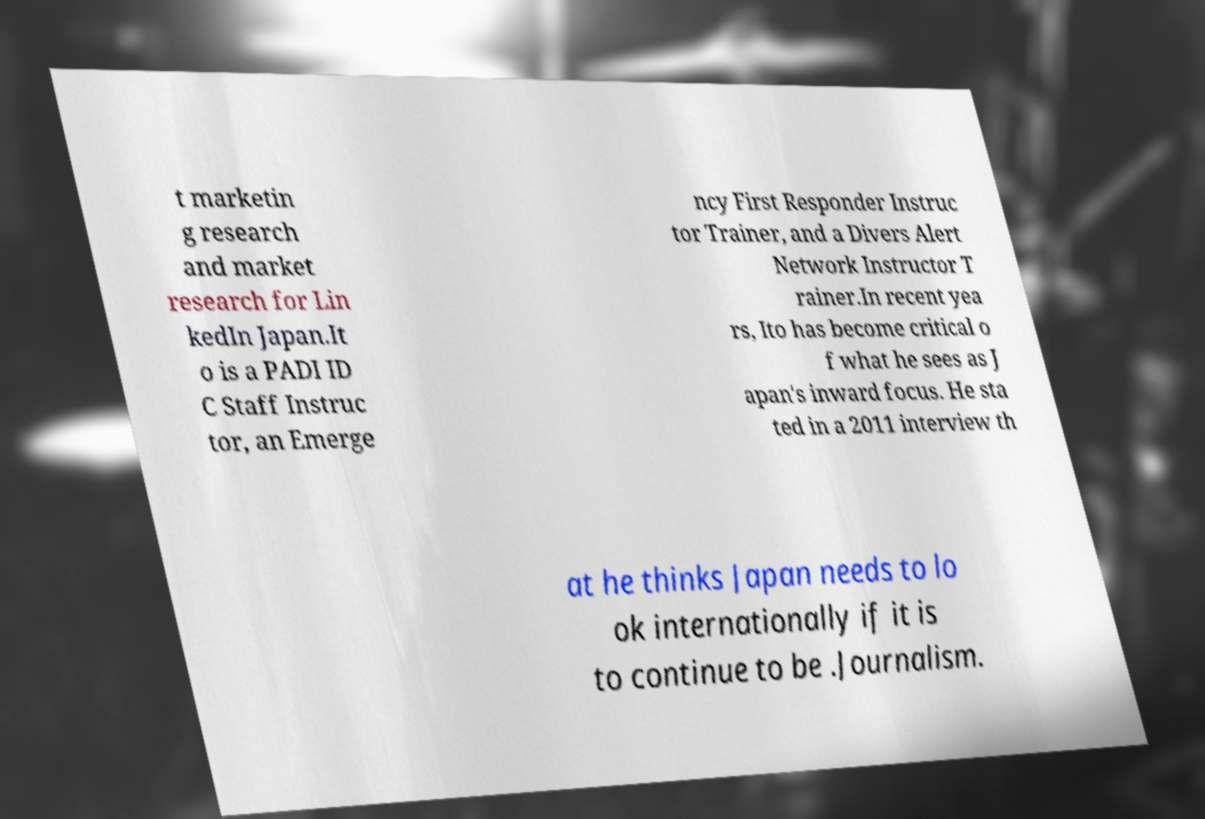Please identify and transcribe the text found in this image. t marketin g research and market research for Lin kedIn Japan.It o is a PADI ID C Staff Instruc tor, an Emerge ncy First Responder Instruc tor Trainer, and a Divers Alert Network Instructor T rainer.In recent yea rs, Ito has become critical o f what he sees as J apan's inward focus. He sta ted in a 2011 interview th at he thinks Japan needs to lo ok internationally if it is to continue to be .Journalism. 